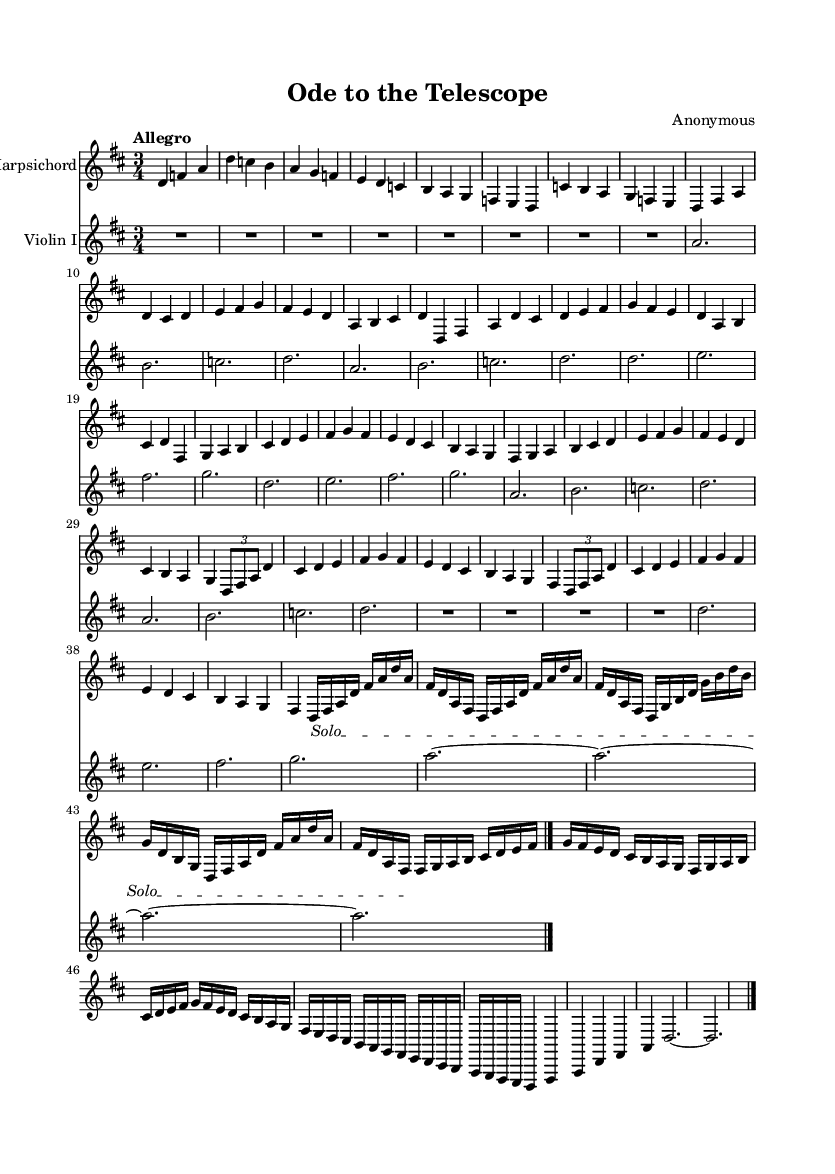What is the key signature of this music? The key signature is indicated by the sharp symbols at the beginning of the staff. In this case, there are two sharps, which means the key is D major.
Answer: D major What is the time signature of this music? The time signature is found at the beginning of the staff, represented as a fraction. Here, it is 3/4, which indicates three beats per measure and a quarter note receives one beat.
Answer: 3/4 What is the tempo marking of the music? The tempo marking is shown at the beginning of the score and sets the speed of the piece. It reads "Allegro," indicating a lively and fast tempo.
Answer: Allegro How many measures are in the "Theme A" section? To find the number of measures, we look at the notation for Theme A, which spans from the beginning to the end of that section. It's visible that there are 8 measures in that section.
Answer: 8 What is the technique indicated during the solo passage? The solo passage is marked with a text spanner that states "Solo," indicating that the harpsichord is highlighted during this part of the piece.
Answer: Solo What is the time signature of the "Coda" section? The "Coda" section is at the end of the piece, and it retains the same time signature as previously indicated, which is 3/4.
Answer: 3/4 In which section does the harpsichord play alone? The harpsichord plays alone during the "Solo harpsichord passage," which is indicated by the marking and the absence of other instrumental parts.
Answer: Solo harpsichord passage 